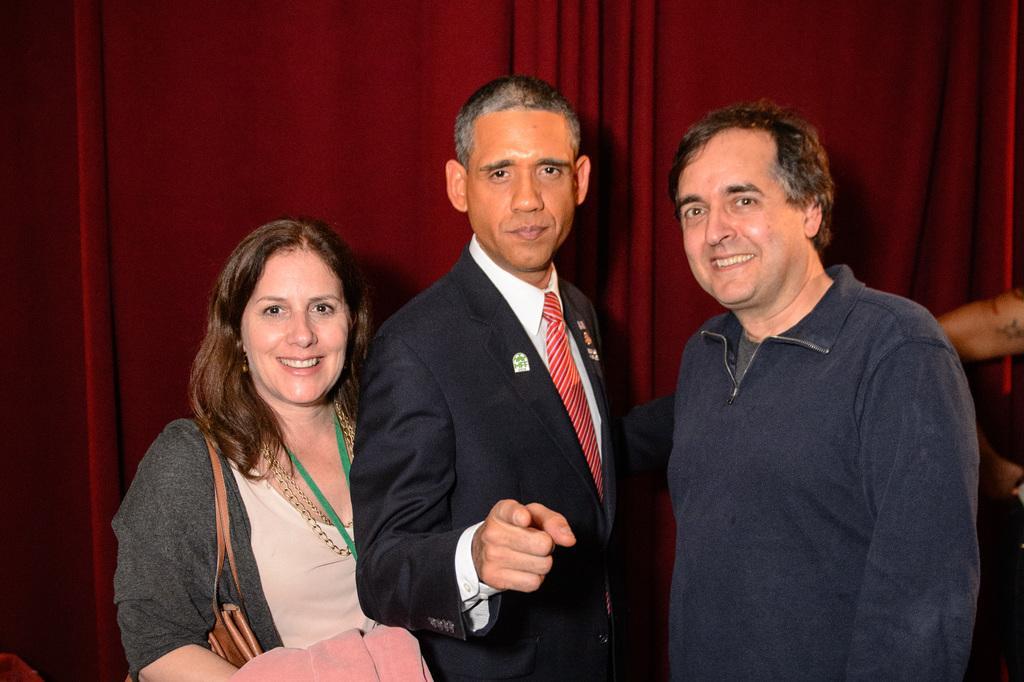How would you summarize this image in a sentence or two? In the image we can see two men and a woman standing, they are wearing clothes and they are smiling. The woman is wearing neck chain and carrying a bag. Behind them, we can see the curtains maroon in colour. 